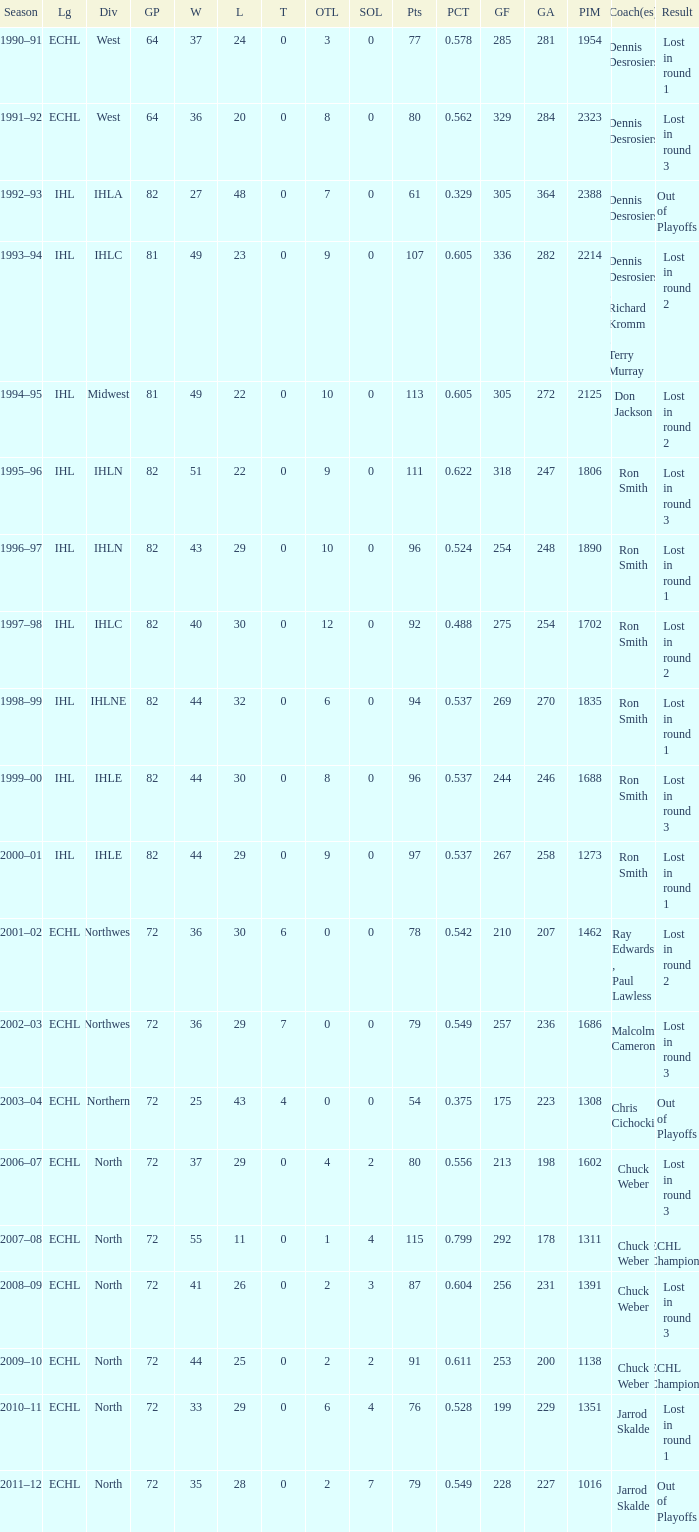What was the season where the team reached a GP of 244? 1999–00. 